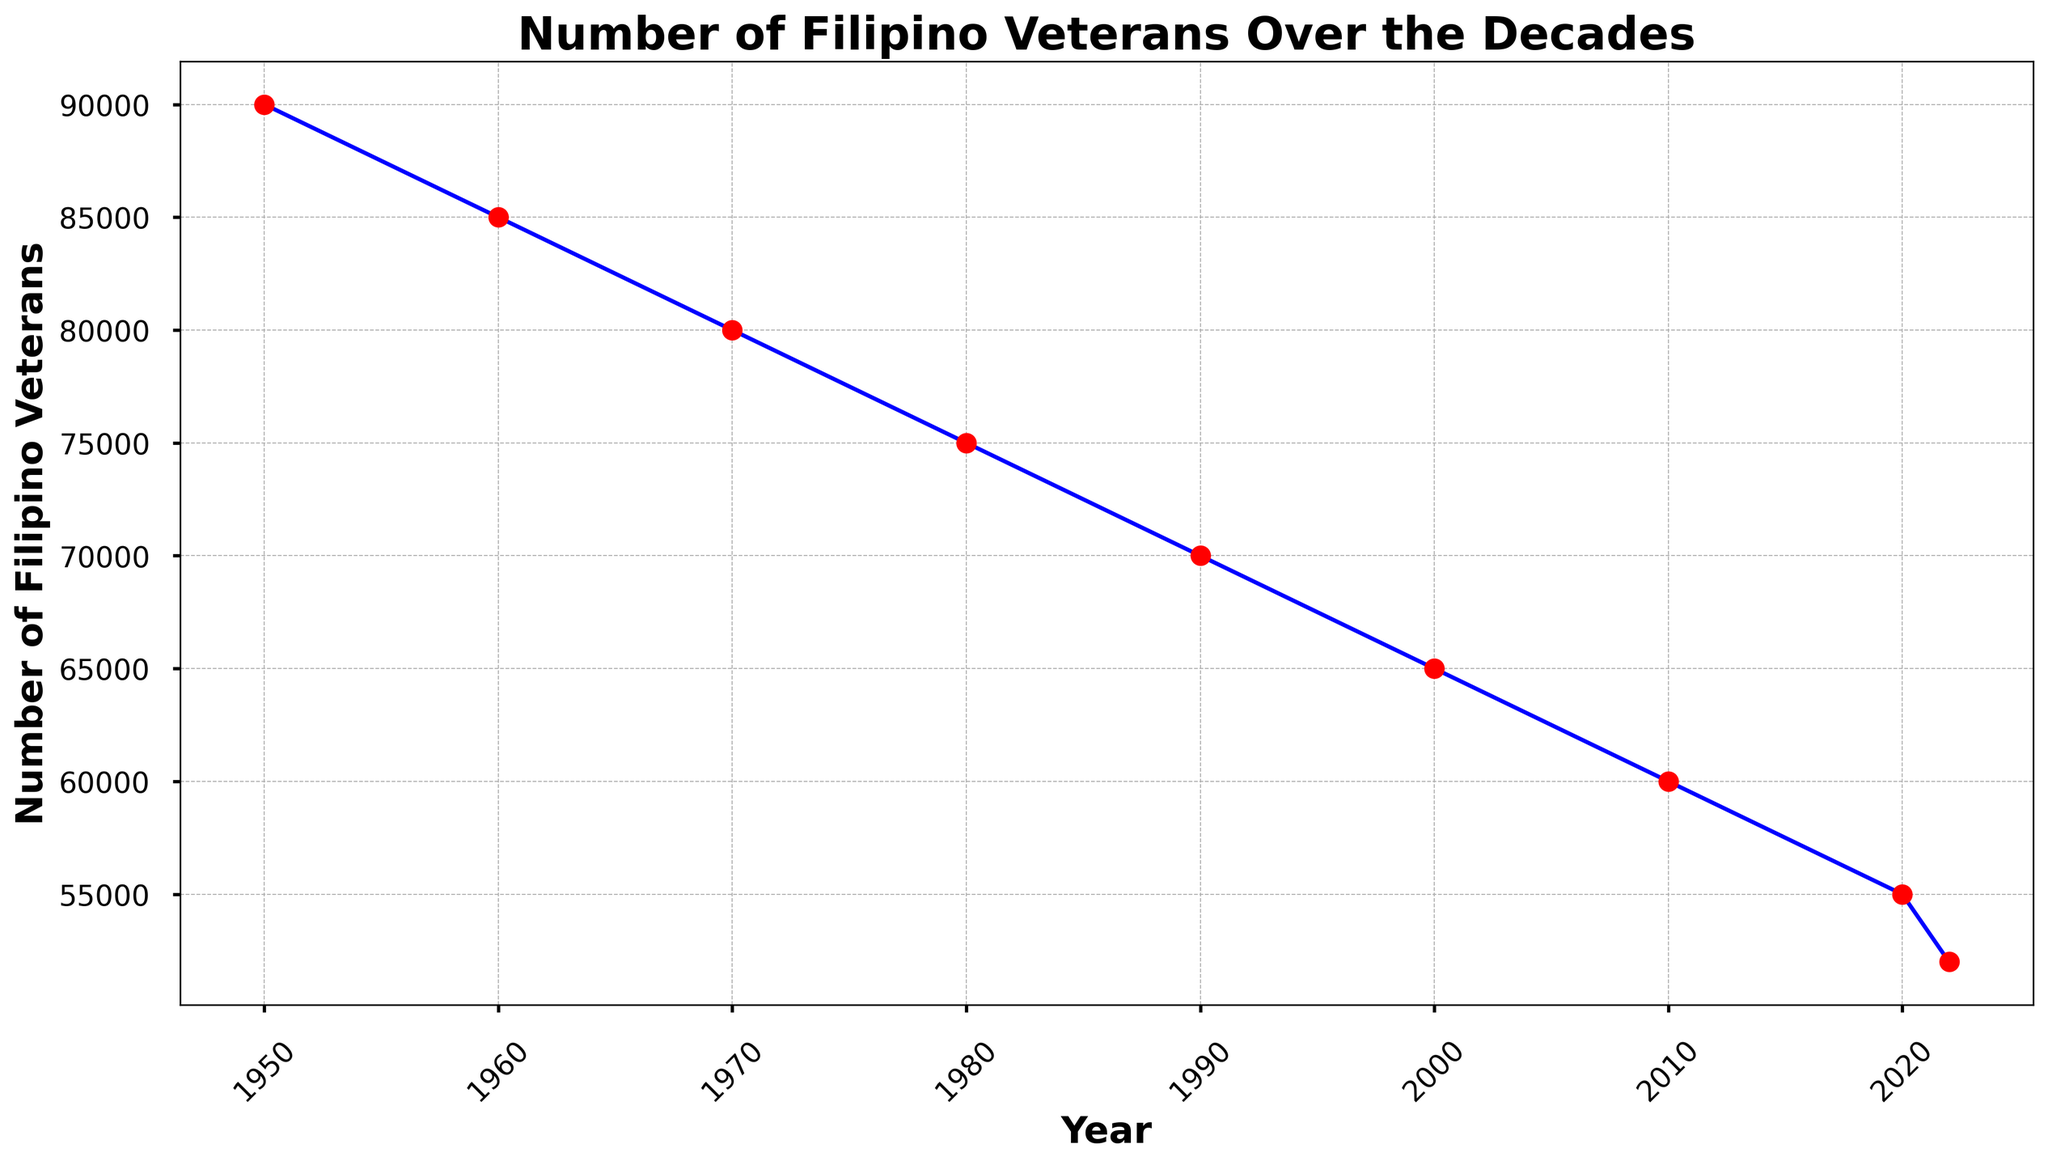What was the number of Filipino veterans in 1980? Refer to the data point for the year 1980 on the line chart, which shows the number of Filipino veterans.
Answer: 75000 Which decade saw the sharpest decline in the number of Filipino veterans? Observe the steepest slope in the line plot to see which decade had the greatest decrease in the number of veterans. The slope between 1950 and 1960 appears the steepest.
Answer: 1950s-1960s By how much did the number of Filipino veterans decrease between 2000 and 2020? Subtract the number of Filipino veterans in 2020 from the number in 2000: 65000 - 55000 = 10000.
Answer: 10000 How did the number of Filipino veterans change between 2020 and 2022? Compare the data points for 2020 and 2022; subtract the 2022 value from the 2020 value: 55000 - 52000 = 3000.
Answer: 3000 What is the overall trend in the number of Filipino veterans over the decades? Examine the line chart from start to end; it consistently slopes downward, indicating a continuous decrease over time.
Answer: Decreasing In which year was the number of Filipino veterans the highest? Look for the highest point on the Y-axis and find the corresponding year on the X-axis. The number is highest in 1950.
Answer: 1950 What is the average number of Filipino veterans between 1950 and 2022? Sum up the number of veterans from all years listed and divide by the number of years: (90000 + 85000 + 80000 + 75000 + 70000 + 65000 + 60000 + 55000 + 52000) / 9 = 70333.33.
Answer: 70333.33 Was the decline in the number of veterans between 1970 and 1980 greater than between 1960 and 1970? Calculate the differences:
1970-1980: 80000 - 75000 = 5000
1960-1970: 85000 - 80000 = 5000
Compare the values; they are equal.
Answer: No, they are equal How many years did it take for the number of Filipino veterans to decrease from 70000 to 52000? Identify when the number was 70000 (1990) and when it reached 52000 (2022), then subtract the years: 2022 - 1990 = 32.
Answer: 32 What visual attributes help distinguish different time periods on the chart? The line is marked with blue color and red markers, with years labeled on the X-axis.
Answer: Blue line, red markers, labeled years 